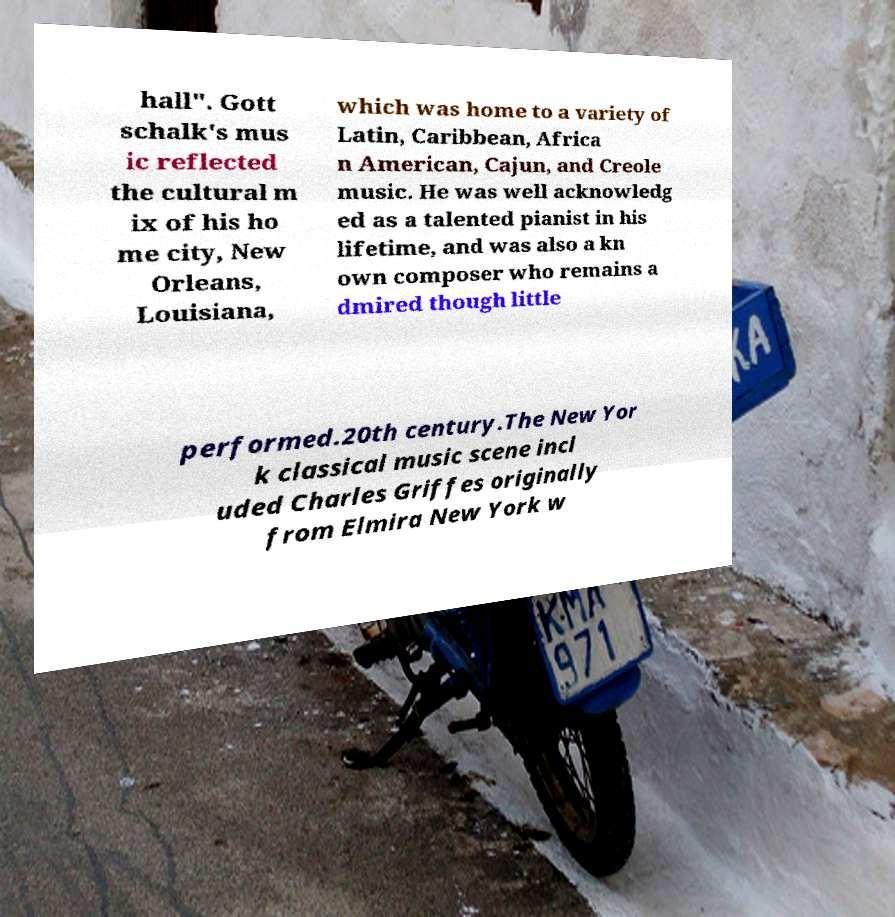Could you assist in decoding the text presented in this image and type it out clearly? hall". Gott schalk's mus ic reflected the cultural m ix of his ho me city, New Orleans, Louisiana, which was home to a variety of Latin, Caribbean, Africa n American, Cajun, and Creole music. He was well acknowledg ed as a talented pianist in his lifetime, and was also a kn own composer who remains a dmired though little performed.20th century.The New Yor k classical music scene incl uded Charles Griffes originally from Elmira New York w 